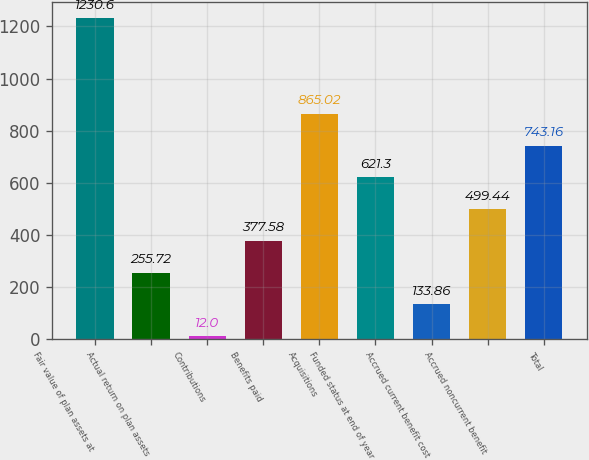Convert chart to OTSL. <chart><loc_0><loc_0><loc_500><loc_500><bar_chart><fcel>Fair value of plan assets at<fcel>Actual return on plan assets<fcel>Contributions<fcel>Benefits paid<fcel>Acquisitions<fcel>Funded status at end of year<fcel>Accrued current benefit cost<fcel>Accrued noncurrent benefit<fcel>Total<nl><fcel>1230.6<fcel>255.72<fcel>12<fcel>377.58<fcel>865.02<fcel>621.3<fcel>133.86<fcel>499.44<fcel>743.16<nl></chart> 